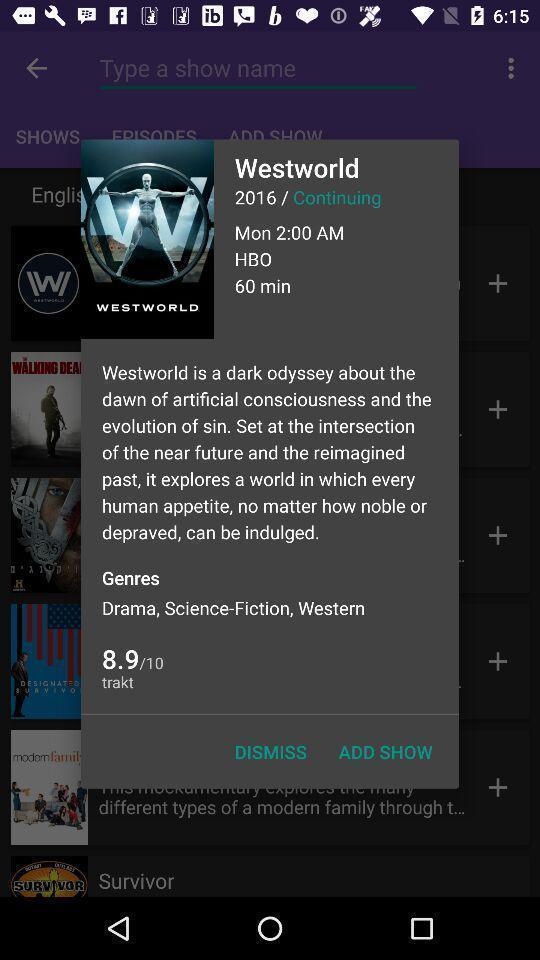What can you discern from this picture? Pop up shows to add shows. 